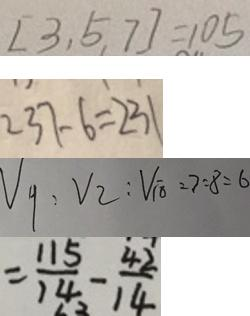Convert formula to latex. <formula><loc_0><loc_0><loc_500><loc_500>[ 3 , 5 , 7 ] = 1 0 5 
 2 3 7 - 6 = 2 3 1 
 V _ { 甲 } : V _ { 乙 } : V _ { 丙 } = 7 : 8 : 6 
 = \frac { 1 1 5 } { 1 4 } - \frac { 4 2 } { 1 4 }</formula> 